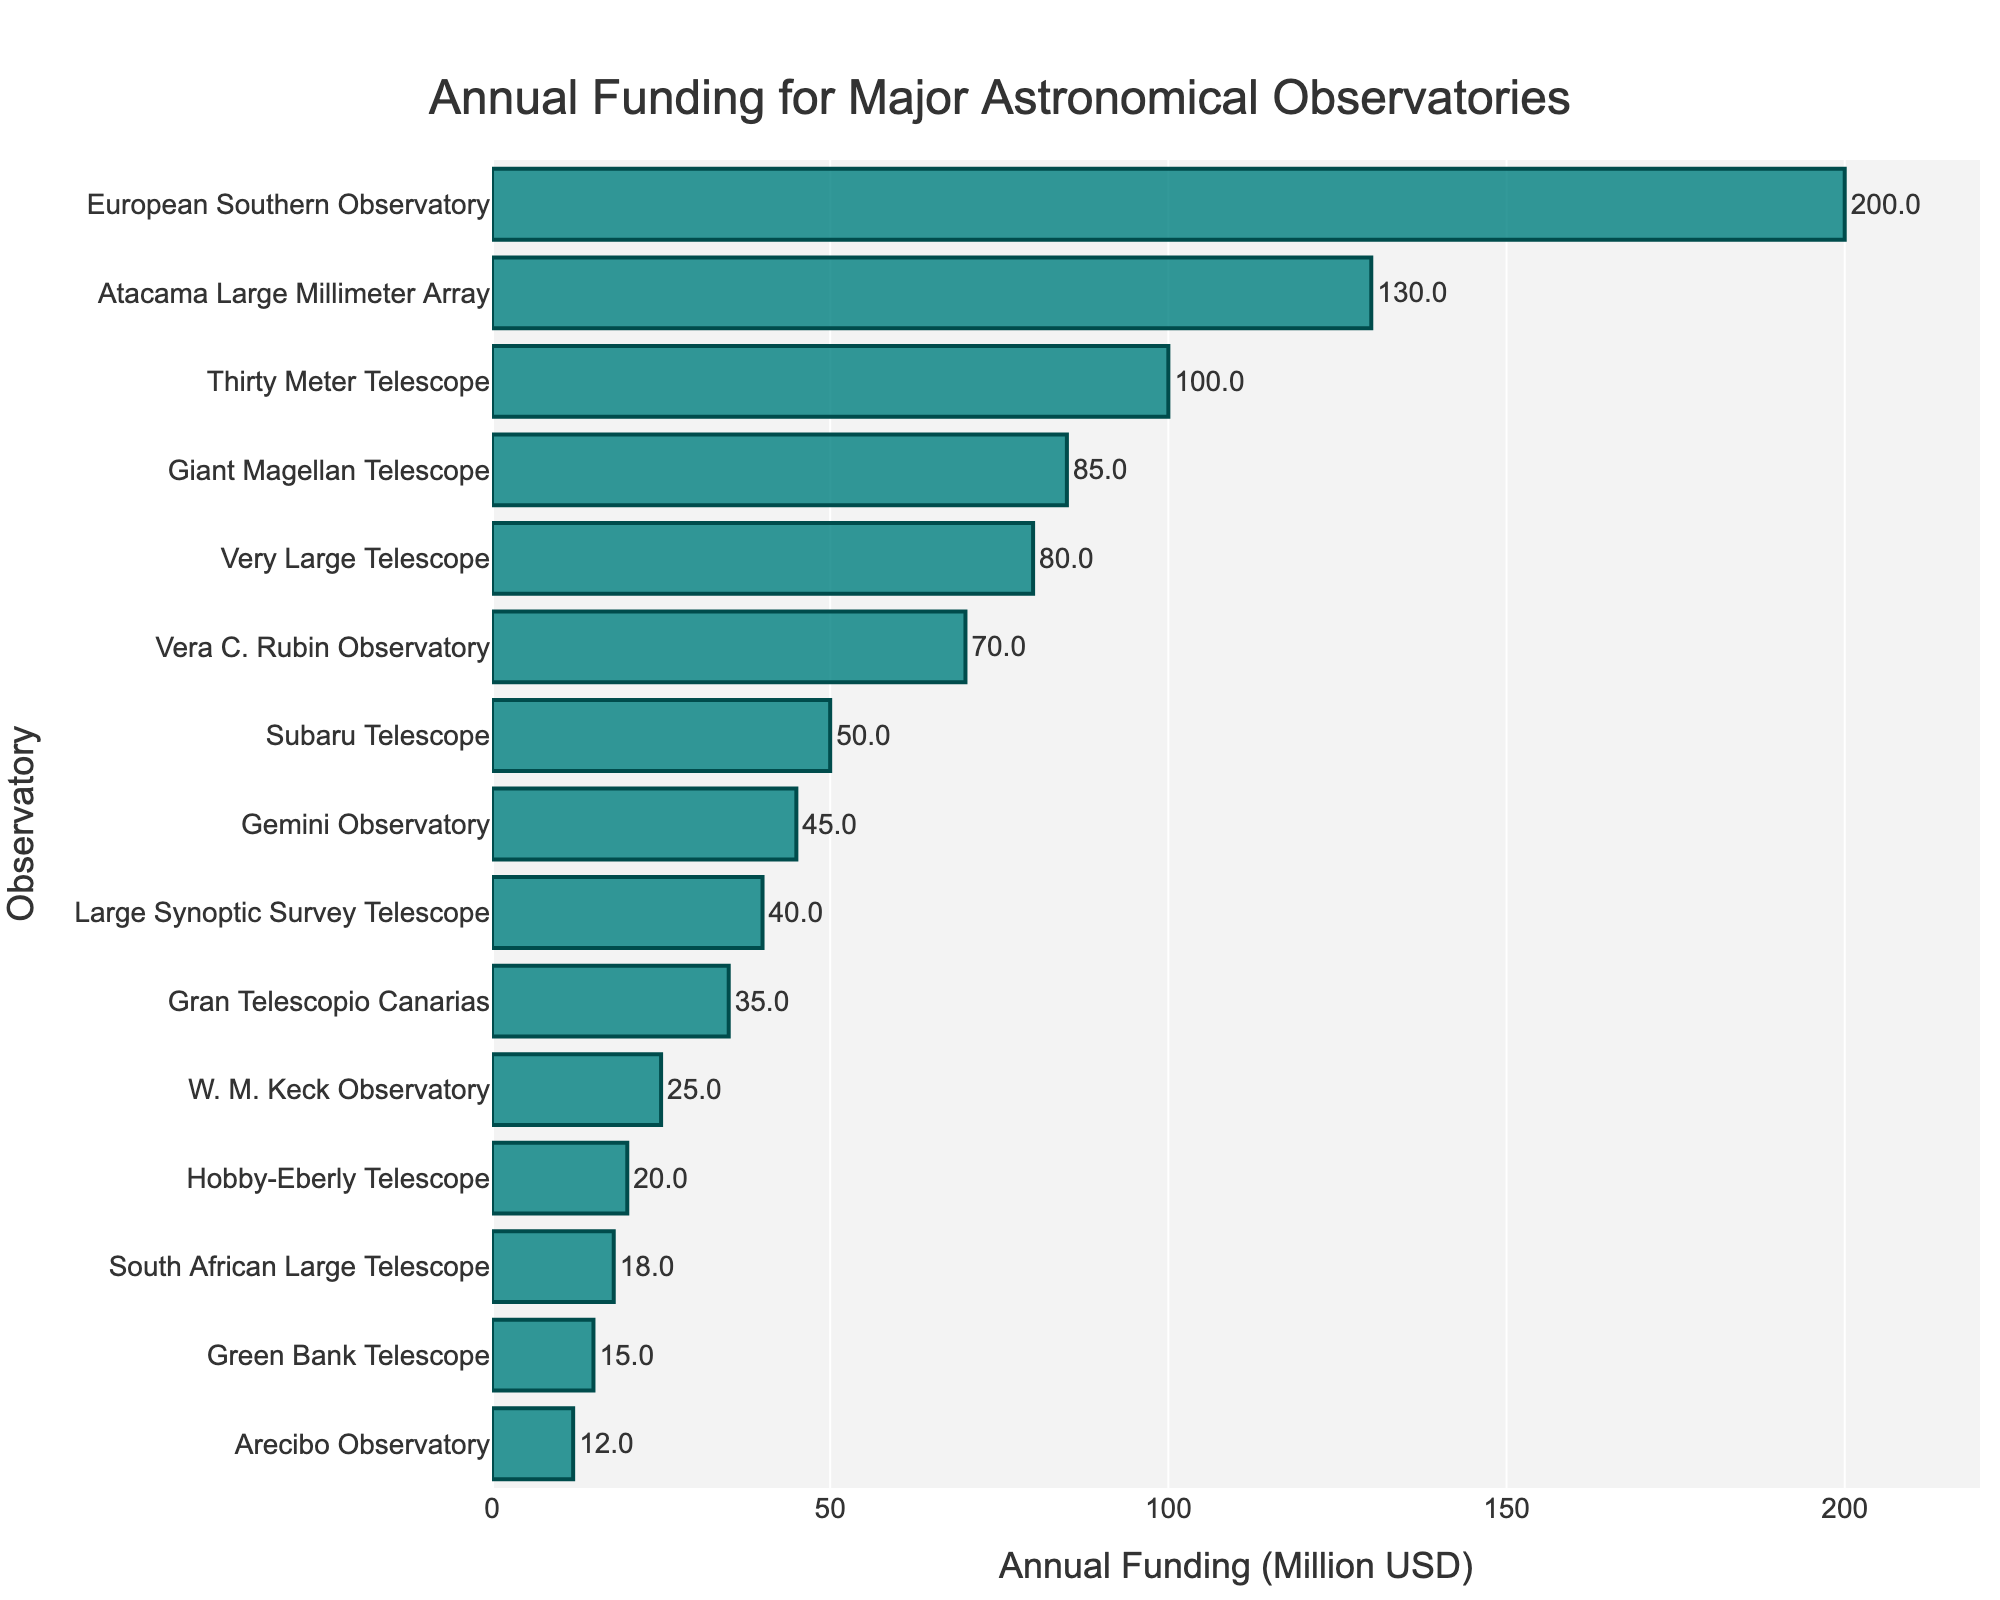Which observatory has the highest annual funding? The observatory with the highest annual funding can be identified by observing the longest bar on the chart. The longest bar corresponds to the European Southern Observatory, which receives an annual funding of 200 million USD.
Answer: European Southern Observatory Which observatories receive less than 20 million USD in annual funding? To find observatories with less than 20 million USD in annual funding, look for bars that are shorter and closer to the left side of the funding axis. The observatories meeting this criterion are Green Bank Telescope, Arecibo Observatory, and South African Large Telescope.
Answer: Green Bank Telescope, Arecibo Observatory, South African Large Telescope What is the total annual funding for the Giant Magellan Telescope and Very Large Telescope combined? To calculate the total funding for both observatories, sum their individual funding amounts. The Giant Magellan Telescope has an annual funding of 85 million USD and the Very Large Telescope has 80 million USD. Therefore, 85 + 80 = 165 million USD.
Answer: 165 million USD Which telescope has a funding amount that is closest to the average funding across all observatories? First, compute the average funding by summing all the funding amounts and dividing by the number of observatories. Sum = 200 + 25 + 130 + 80 + 50 + 45 + 35 + 40 + 100 + 70 + 15 + 12 + 20 + 18 + 85 = 925 million USD. The average is 925/15 ≈ 61.67 million USD. Observatories closest to this amount are Subaru Telescope and Gemini Observatory, with 50 and 45 million USD respectively. Subaru Telescope is closer to this average.
Answer: Subaru Telescope By how much does the funding for the European Southern Observatory exceed that of the Atacama Large Millimeter Array? To determine the difference in funding, subtract the annual funding of the Atacama Large Millimeter Array from that of the European Southern Observatory. The difference is 200 - 130 = 70 million USD.
Answer: 70 million USD What is the median annual funding for these observatories? To find the median, list the funding amounts in ascending order and identify the middle value. The ordered amounts are: 12, 15, 18, 20, 25, 35, 40, 45, 50, 70, 80, 85, 100, 130, 200. The middle value, which is the 8th value in this 15-item list, is 45 million USD.
Answer: 45 million USD Which observatory has the shortest bar indicating the least amount of funding? The observatory with the shortest bar is the one on the extreme left of the funding axis. The shortest bar corresponds to the Arecibo Observatory, which receives 12 million USD annually.
Answer: Arecibo Observatory How many observatories have an annual funding greater than 50 million USD? Count the number of bars that extend beyond the 50 million USD mark. Observatories with funding greater than 50 million USD include European Southern Observatory, Atacama Large Millimeter Array, Very Large Telescope, Thirty Meter Telescope, Vera C. Rubin Observatory, and Giant Magellan Telescope. This results in a total of 6 observatories.
Answer: 6 